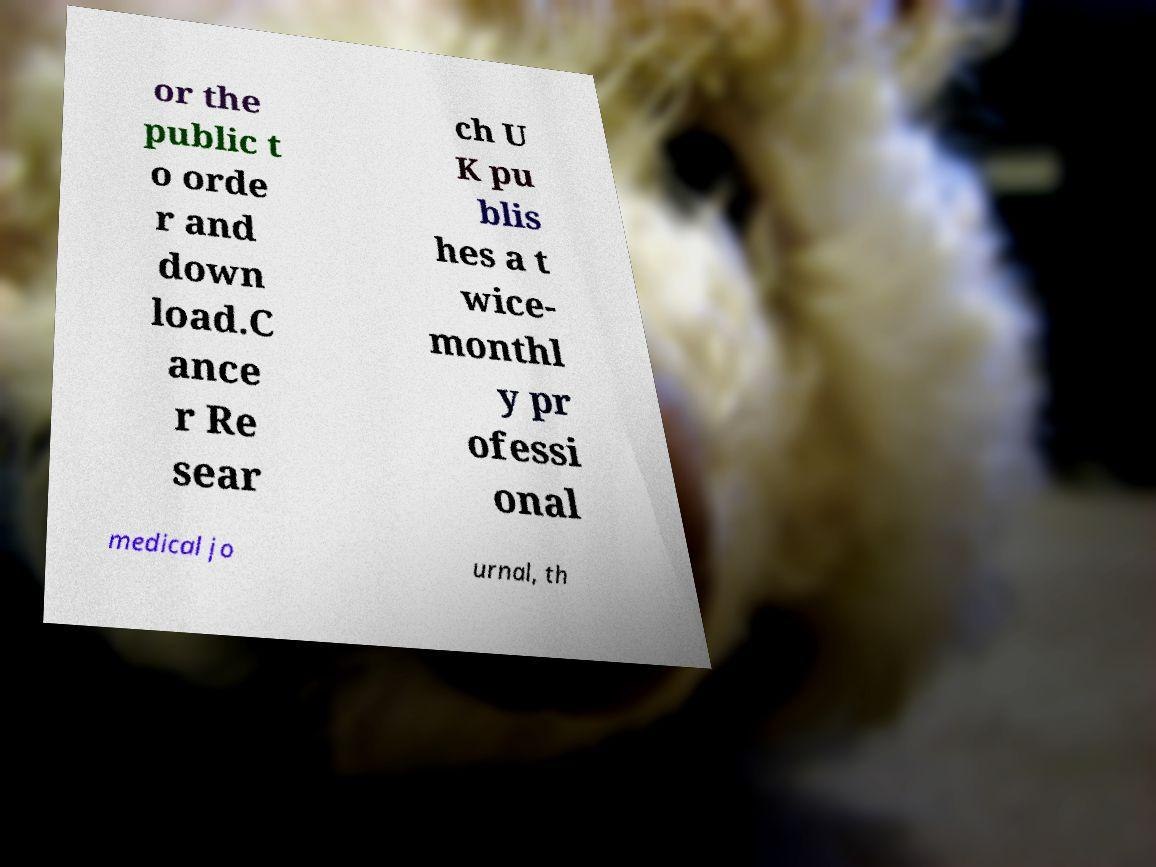Can you read and provide the text displayed in the image?This photo seems to have some interesting text. Can you extract and type it out for me? or the public t o orde r and down load.C ance r Re sear ch U K pu blis hes a t wice- monthl y pr ofessi onal medical jo urnal, th 